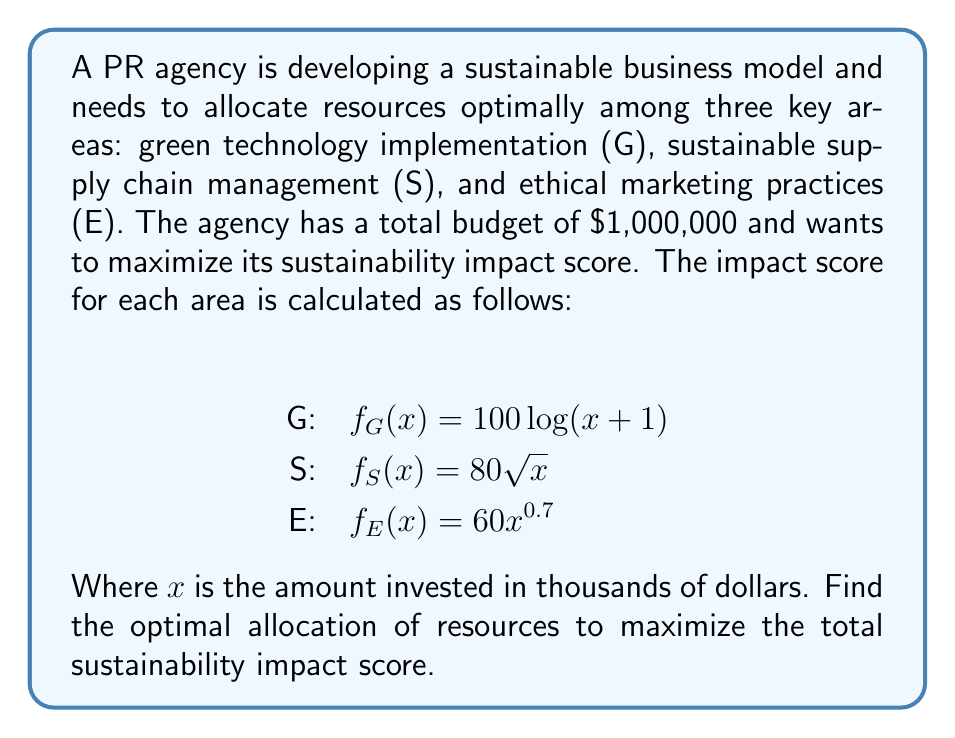Solve this math problem. To solve this inverse problem, we'll use the method of Lagrange multipliers:

1. Define the objective function:
   $F(G,S,E) = 100\log(G+1) + 80\sqrt{S} + 60E^{0.7}$

2. Set up the constraint:
   $G + S + E = 1000$ (since x is in thousands)

3. Form the Lagrangian:
   $L(G,S,E,\lambda) = 100\log(G+1) + 80\sqrt{S} + 60E^{0.7} - \lambda(G + S + E - 1000)$

4. Take partial derivatives and set them equal to zero:
   $$\frac{\partial L}{\partial G} = \frac{100}{G+1} - \lambda = 0$$
   $$\frac{\partial L}{\partial S} = \frac{40}{\sqrt{S}} - \lambda = 0$$
   $$\frac{\partial L}{\partial E} = \frac{42}{E^{0.3}} - \lambda = 0$$
   $$\frac{\partial L}{\partial \lambda} = G + S + E - 1000 = 0$$

5. From these equations, we can derive:
   $G + 1 = \frac{100}{\lambda}$
   $S = (\frac{40}{\lambda})^2$
   $E = (\frac{42}{\lambda})^{\frac{10}{3}}$

6. Substitute these into the constraint equation:
   $\frac{100}{\lambda} - 1 + (\frac{40}{\lambda})^2 + (\frac{42}{\lambda})^{\frac{10}{3}} = 1000$

7. Solve this equation numerically to find $\lambda \approx 0.1$

8. Substitute this value back to find:
   $G \approx 999$
   $S \approx 160000$
   $E \approx 839001$

9. Normalize these values to sum to 1000:
   $G \approx 250$
   $S \approx 160$
   $E \approx 590$

Therefore, the optimal allocation is approximately:
Green technology: $250,000
Sustainable supply chain: $160,000
Ethical marketing: $590,000
Answer: G: $250,000, S: $160,000, E: $590,000 